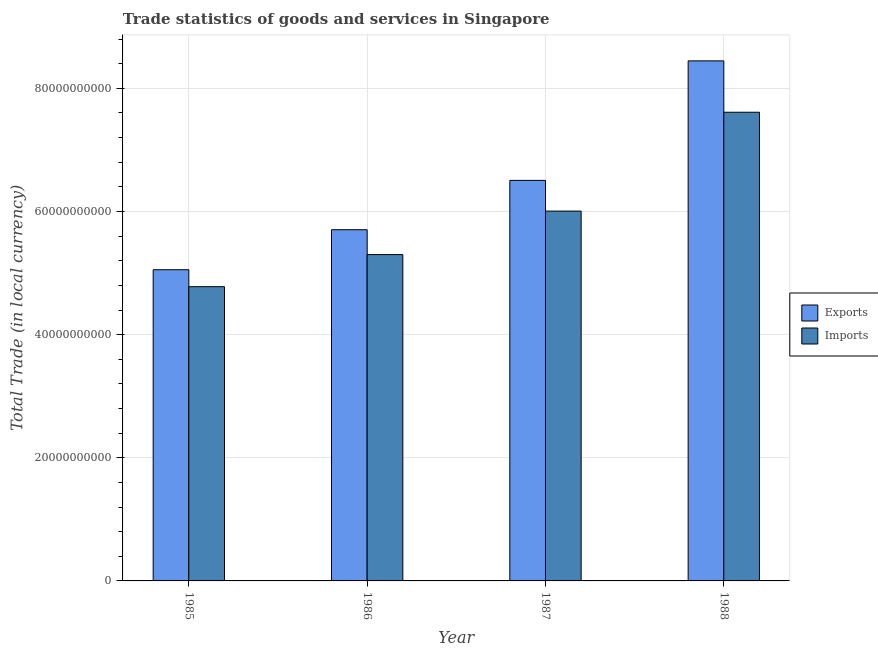Are the number of bars on each tick of the X-axis equal?
Offer a terse response. Yes. How many bars are there on the 3rd tick from the left?
Your answer should be compact. 2. How many bars are there on the 3rd tick from the right?
Your answer should be compact. 2. What is the label of the 3rd group of bars from the left?
Provide a short and direct response. 1987. What is the imports of goods and services in 1986?
Give a very brief answer. 5.30e+1. Across all years, what is the maximum imports of goods and services?
Your response must be concise. 7.61e+1. Across all years, what is the minimum imports of goods and services?
Provide a succinct answer. 4.78e+1. In which year was the imports of goods and services minimum?
Your answer should be very brief. 1985. What is the total export of goods and services in the graph?
Your answer should be compact. 2.57e+11. What is the difference between the imports of goods and services in 1986 and that in 1987?
Provide a succinct answer. -7.06e+09. What is the difference between the imports of goods and services in 1988 and the export of goods and services in 1985?
Ensure brevity in your answer.  2.83e+1. What is the average export of goods and services per year?
Ensure brevity in your answer.  6.43e+1. In the year 1986, what is the difference between the export of goods and services and imports of goods and services?
Offer a terse response. 0. In how many years, is the export of goods and services greater than 24000000000 LCU?
Ensure brevity in your answer.  4. What is the ratio of the imports of goods and services in 1986 to that in 1987?
Offer a very short reply. 0.88. What is the difference between the highest and the second highest imports of goods and services?
Your answer should be compact. 1.61e+1. What is the difference between the highest and the lowest export of goods and services?
Your answer should be very brief. 3.39e+1. Is the sum of the export of goods and services in 1985 and 1988 greater than the maximum imports of goods and services across all years?
Your answer should be compact. Yes. What does the 2nd bar from the left in 1986 represents?
Make the answer very short. Imports. What does the 1st bar from the right in 1986 represents?
Give a very brief answer. Imports. How many years are there in the graph?
Give a very brief answer. 4. Are the values on the major ticks of Y-axis written in scientific E-notation?
Offer a terse response. No. Does the graph contain any zero values?
Ensure brevity in your answer.  No. Where does the legend appear in the graph?
Give a very brief answer. Center right. What is the title of the graph?
Your answer should be very brief. Trade statistics of goods and services in Singapore. Does "Primary education" appear as one of the legend labels in the graph?
Offer a very short reply. No. What is the label or title of the Y-axis?
Provide a short and direct response. Total Trade (in local currency). What is the Total Trade (in local currency) in Exports in 1985?
Your response must be concise. 5.05e+1. What is the Total Trade (in local currency) of Imports in 1985?
Make the answer very short. 4.78e+1. What is the Total Trade (in local currency) of Exports in 1986?
Ensure brevity in your answer.  5.70e+1. What is the Total Trade (in local currency) of Imports in 1986?
Your response must be concise. 5.30e+1. What is the Total Trade (in local currency) in Exports in 1987?
Your answer should be compact. 6.51e+1. What is the Total Trade (in local currency) of Imports in 1987?
Keep it short and to the point. 6.01e+1. What is the Total Trade (in local currency) in Exports in 1988?
Offer a very short reply. 8.45e+1. What is the Total Trade (in local currency) in Imports in 1988?
Your response must be concise. 7.61e+1. Across all years, what is the maximum Total Trade (in local currency) in Exports?
Provide a succinct answer. 8.45e+1. Across all years, what is the maximum Total Trade (in local currency) of Imports?
Give a very brief answer. 7.61e+1. Across all years, what is the minimum Total Trade (in local currency) in Exports?
Your answer should be very brief. 5.05e+1. Across all years, what is the minimum Total Trade (in local currency) of Imports?
Provide a succinct answer. 4.78e+1. What is the total Total Trade (in local currency) of Exports in the graph?
Ensure brevity in your answer.  2.57e+11. What is the total Total Trade (in local currency) of Imports in the graph?
Keep it short and to the point. 2.37e+11. What is the difference between the Total Trade (in local currency) in Exports in 1985 and that in 1986?
Give a very brief answer. -6.50e+09. What is the difference between the Total Trade (in local currency) in Imports in 1985 and that in 1986?
Your answer should be very brief. -5.21e+09. What is the difference between the Total Trade (in local currency) in Exports in 1985 and that in 1987?
Make the answer very short. -1.45e+1. What is the difference between the Total Trade (in local currency) in Imports in 1985 and that in 1987?
Your answer should be very brief. -1.23e+1. What is the difference between the Total Trade (in local currency) in Exports in 1985 and that in 1988?
Your response must be concise. -3.39e+1. What is the difference between the Total Trade (in local currency) in Imports in 1985 and that in 1988?
Your response must be concise. -2.83e+1. What is the difference between the Total Trade (in local currency) of Exports in 1986 and that in 1987?
Offer a very short reply. -8.01e+09. What is the difference between the Total Trade (in local currency) of Imports in 1986 and that in 1987?
Give a very brief answer. -7.06e+09. What is the difference between the Total Trade (in local currency) in Exports in 1986 and that in 1988?
Your response must be concise. -2.74e+1. What is the difference between the Total Trade (in local currency) of Imports in 1986 and that in 1988?
Ensure brevity in your answer.  -2.31e+1. What is the difference between the Total Trade (in local currency) of Exports in 1987 and that in 1988?
Offer a very short reply. -1.94e+1. What is the difference between the Total Trade (in local currency) in Imports in 1987 and that in 1988?
Give a very brief answer. -1.61e+1. What is the difference between the Total Trade (in local currency) in Exports in 1985 and the Total Trade (in local currency) in Imports in 1986?
Make the answer very short. -2.46e+09. What is the difference between the Total Trade (in local currency) of Exports in 1985 and the Total Trade (in local currency) of Imports in 1987?
Offer a terse response. -9.53e+09. What is the difference between the Total Trade (in local currency) of Exports in 1985 and the Total Trade (in local currency) of Imports in 1988?
Your response must be concise. -2.56e+1. What is the difference between the Total Trade (in local currency) of Exports in 1986 and the Total Trade (in local currency) of Imports in 1987?
Your answer should be compact. -3.03e+09. What is the difference between the Total Trade (in local currency) of Exports in 1986 and the Total Trade (in local currency) of Imports in 1988?
Your answer should be compact. -1.91e+1. What is the difference between the Total Trade (in local currency) in Exports in 1987 and the Total Trade (in local currency) in Imports in 1988?
Offer a terse response. -1.11e+1. What is the average Total Trade (in local currency) of Exports per year?
Your response must be concise. 6.43e+1. What is the average Total Trade (in local currency) of Imports per year?
Provide a succinct answer. 5.92e+1. In the year 1985, what is the difference between the Total Trade (in local currency) in Exports and Total Trade (in local currency) in Imports?
Your answer should be compact. 2.75e+09. In the year 1986, what is the difference between the Total Trade (in local currency) of Exports and Total Trade (in local currency) of Imports?
Ensure brevity in your answer.  4.04e+09. In the year 1987, what is the difference between the Total Trade (in local currency) in Exports and Total Trade (in local currency) in Imports?
Provide a short and direct response. 4.99e+09. In the year 1988, what is the difference between the Total Trade (in local currency) of Exports and Total Trade (in local currency) of Imports?
Your answer should be very brief. 8.34e+09. What is the ratio of the Total Trade (in local currency) in Exports in 1985 to that in 1986?
Offer a very short reply. 0.89. What is the ratio of the Total Trade (in local currency) in Imports in 1985 to that in 1986?
Offer a very short reply. 0.9. What is the ratio of the Total Trade (in local currency) in Exports in 1985 to that in 1987?
Ensure brevity in your answer.  0.78. What is the ratio of the Total Trade (in local currency) in Imports in 1985 to that in 1987?
Ensure brevity in your answer.  0.8. What is the ratio of the Total Trade (in local currency) in Exports in 1985 to that in 1988?
Offer a very short reply. 0.6. What is the ratio of the Total Trade (in local currency) of Imports in 1985 to that in 1988?
Your response must be concise. 0.63. What is the ratio of the Total Trade (in local currency) of Exports in 1986 to that in 1987?
Your response must be concise. 0.88. What is the ratio of the Total Trade (in local currency) in Imports in 1986 to that in 1987?
Provide a succinct answer. 0.88. What is the ratio of the Total Trade (in local currency) of Exports in 1986 to that in 1988?
Ensure brevity in your answer.  0.68. What is the ratio of the Total Trade (in local currency) in Imports in 1986 to that in 1988?
Ensure brevity in your answer.  0.7. What is the ratio of the Total Trade (in local currency) in Exports in 1987 to that in 1988?
Your answer should be very brief. 0.77. What is the ratio of the Total Trade (in local currency) of Imports in 1987 to that in 1988?
Keep it short and to the point. 0.79. What is the difference between the highest and the second highest Total Trade (in local currency) of Exports?
Give a very brief answer. 1.94e+1. What is the difference between the highest and the second highest Total Trade (in local currency) of Imports?
Offer a terse response. 1.61e+1. What is the difference between the highest and the lowest Total Trade (in local currency) of Exports?
Provide a succinct answer. 3.39e+1. What is the difference between the highest and the lowest Total Trade (in local currency) in Imports?
Your response must be concise. 2.83e+1. 